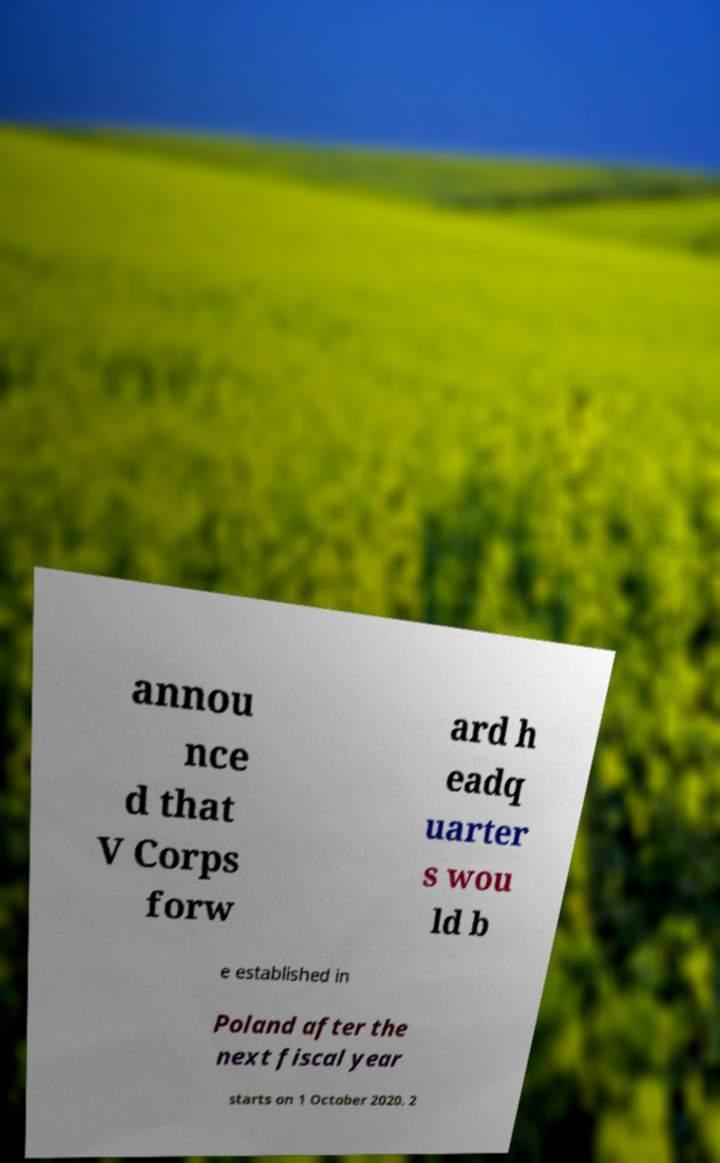I need the written content from this picture converted into text. Can you do that? annou nce d that V Corps forw ard h eadq uarter s wou ld b e established in Poland after the next fiscal year starts on 1 October 2020. 2 